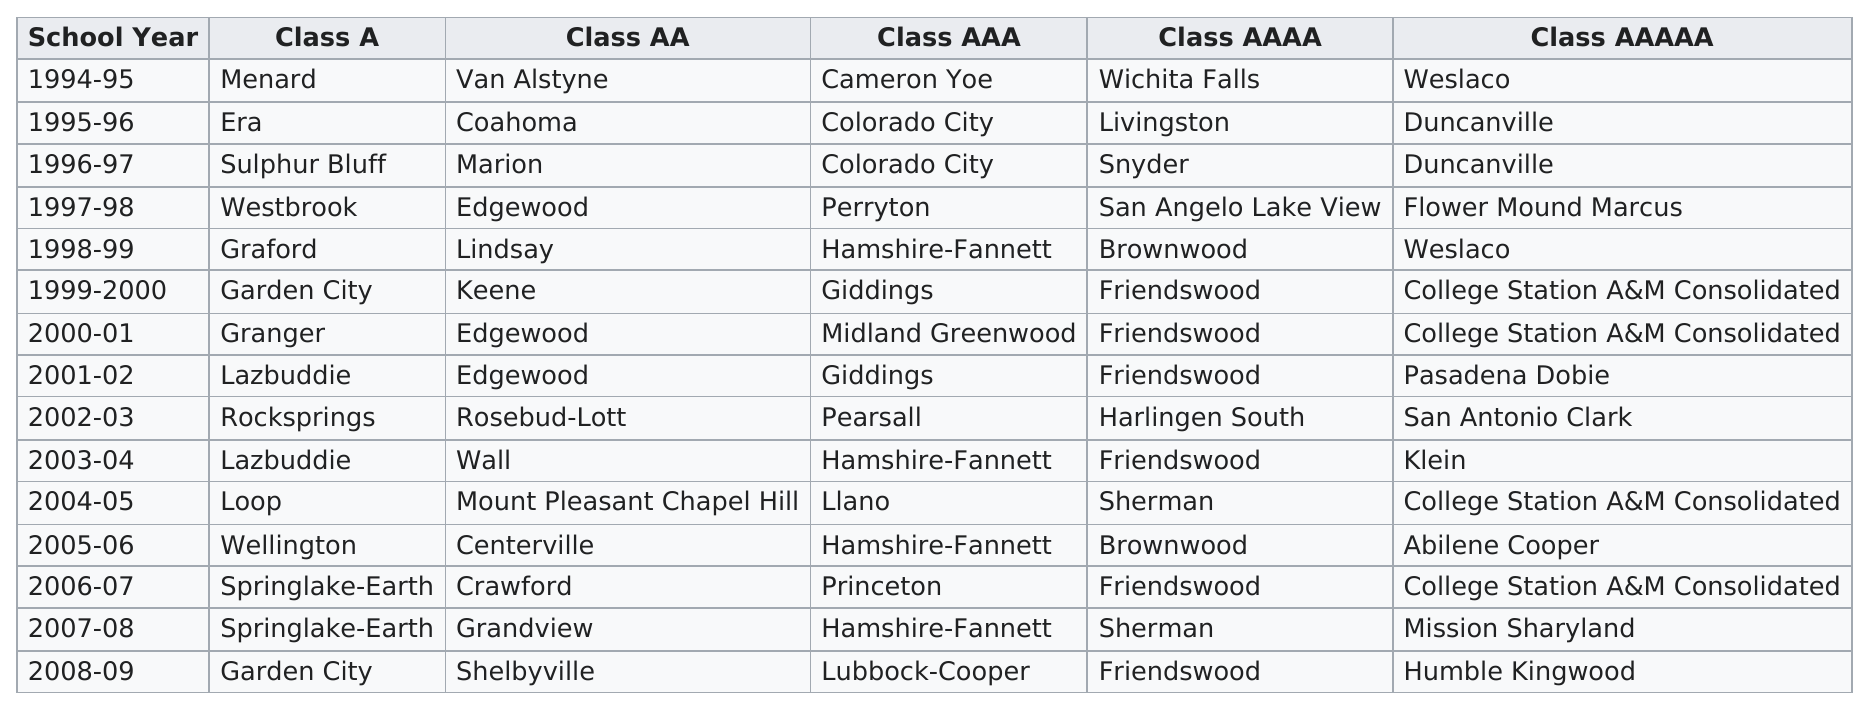Indicate a few pertinent items in this graphic. In the years 1997 to 2003, Friendswood had a total of 3 consecutive wins. College Station A&M Consolidated has won the most in the class aaaaa category. Garden City has won the Class A championship two times. Friendswood won the Class AAAA category six times. The year in which Keene won the Class AA state championship was 1999-2000. 